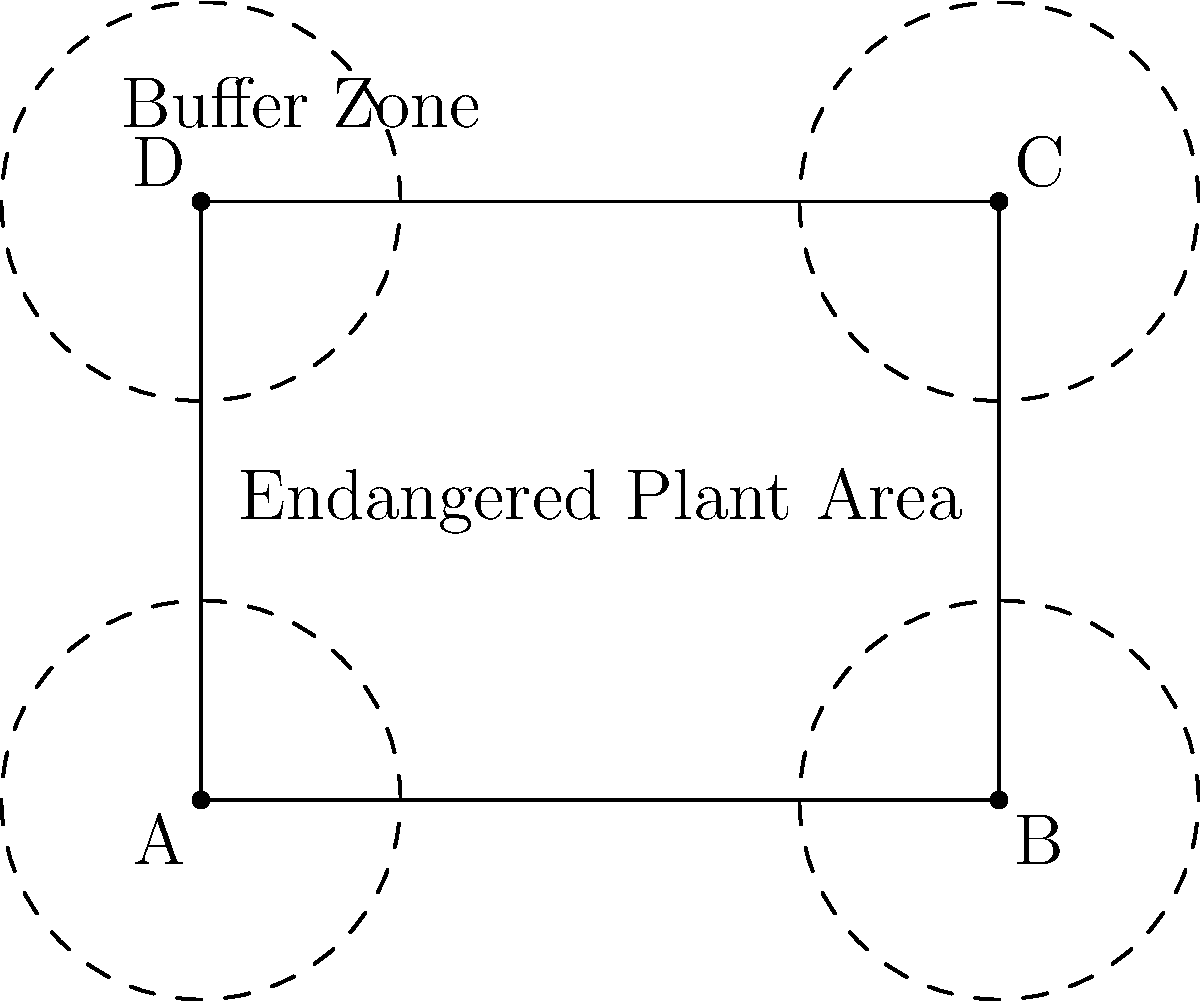A rectangular plot of land measuring 4 units by 3 units contains endangered plant species. To comply with environmental regulations, a buffer zone of 1 unit must be established around the entire perimeter of the plot. If the developer wants to maximize the buildable area while adhering to these regulations, what percentage of the original plot area will be available for development after implementing the buffer zone? To solve this problem, we need to follow these steps:

1. Calculate the original area of the plot:
   Area = length × width
   $A_{\text{original}} = 4 \times 3 = 12$ square units

2. Calculate the dimensions of the reduced buildable area after implementing the buffer zone:
   New length = 4 - 2 = 2 units (1 unit buffer on each side)
   New width = 3 - 2 = 1 unit (1 unit buffer on each side)

3. Calculate the new buildable area:
   $A_{\text{buildable}} = 2 \times 1 = 2$ square units

4. Calculate the percentage of the original area that is available for development:
   Percentage = (Buildable Area / Original Area) × 100
   $\text{Percentage} = \frac{A_{\text{buildable}}}{A_{\text{original}}} \times 100 = \frac{2}{12} \times 100 = \frac{1}{6} \times 100 \approx 16.67\%$

Therefore, approximately 16.67% of the original plot area will be available for development after implementing the required buffer zone.
Answer: 16.67% 